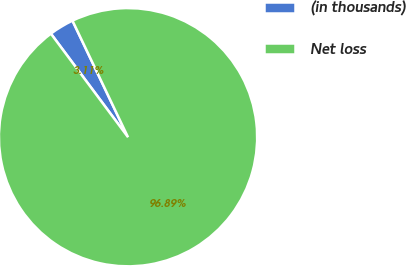Convert chart. <chart><loc_0><loc_0><loc_500><loc_500><pie_chart><fcel>(in thousands)<fcel>Net loss<nl><fcel>3.11%<fcel>96.89%<nl></chart> 